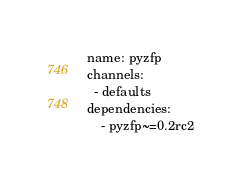<code> <loc_0><loc_0><loc_500><loc_500><_YAML_>
name: pyzfp
channels:
  - defaults
dependencies:
    - pyzfp~=0.2rc2
</code> 